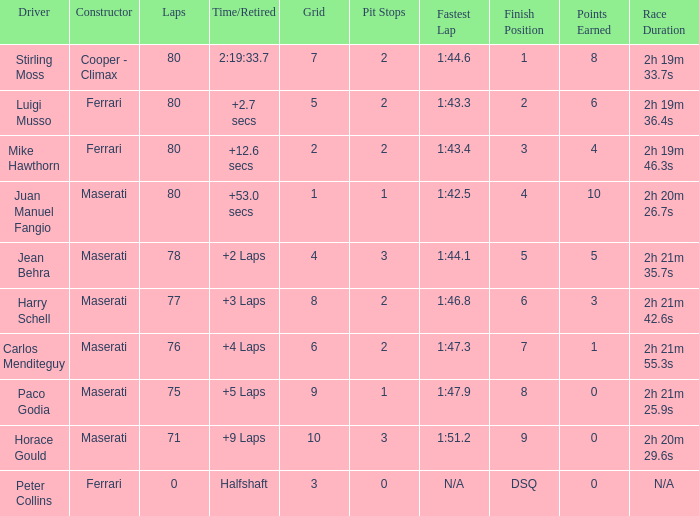Who was driving the Maserati with a Grid smaller than 6, and a Time/Retired of +2 laps? Jean Behra. 